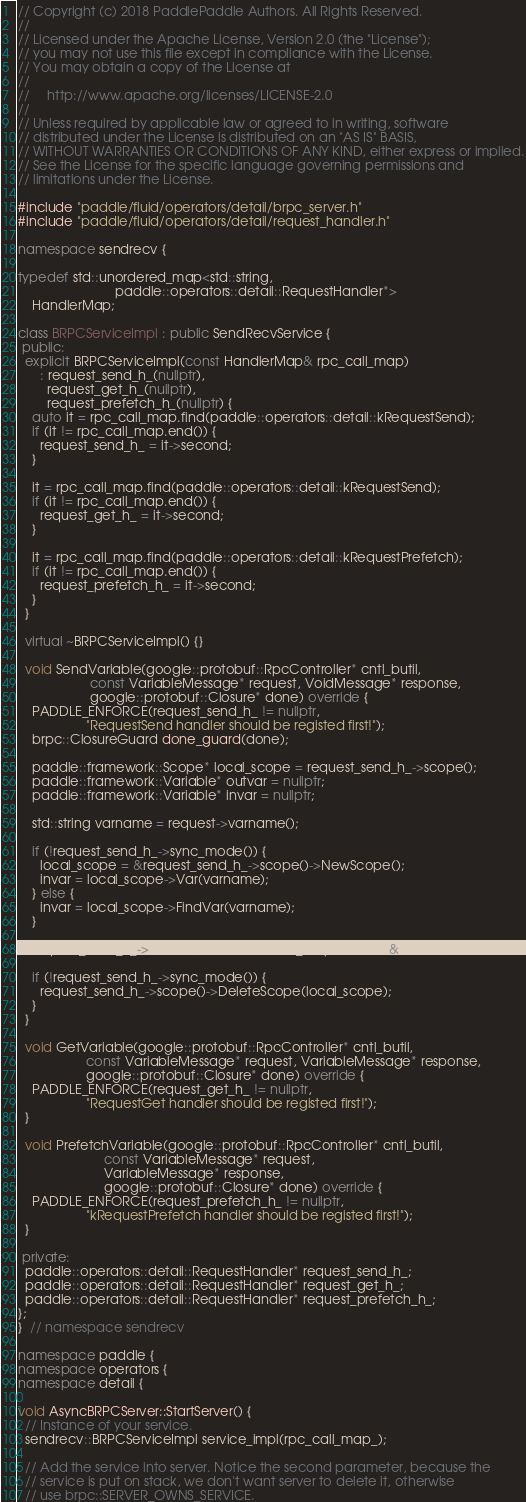<code> <loc_0><loc_0><loc_500><loc_500><_C++_>// Copyright (c) 2018 PaddlePaddle Authors. All Rights Reserved.
//
// Licensed under the Apache License, Version 2.0 (the "License");
// you may not use this file except in compliance with the License.
// You may obtain a copy of the License at
//
//     http://www.apache.org/licenses/LICENSE-2.0
//
// Unless required by applicable law or agreed to in writing, software
// distributed under the License is distributed on an "AS IS" BASIS,
// WITHOUT WARRANTIES OR CONDITIONS OF ANY KIND, either express or implied.
// See the License for the specific language governing permissions and
// limitations under the License.

#include "paddle/fluid/operators/detail/brpc_server.h"
#include "paddle/fluid/operators/detail/request_handler.h"

namespace sendrecv {

typedef std::unordered_map<std::string,
                           paddle::operators::detail::RequestHandler*>
    HandlerMap;

class BRPCServiceImpl : public SendRecvService {
 public:
  explicit BRPCServiceImpl(const HandlerMap& rpc_call_map)
      : request_send_h_(nullptr),
        request_get_h_(nullptr),
        request_prefetch_h_(nullptr) {
    auto it = rpc_call_map.find(paddle::operators::detail::kRequestSend);
    if (it != rpc_call_map.end()) {
      request_send_h_ = it->second;
    }

    it = rpc_call_map.find(paddle::operators::detail::kRequestSend);
    if (it != rpc_call_map.end()) {
      request_get_h_ = it->second;
    }

    it = rpc_call_map.find(paddle::operators::detail::kRequestPrefetch);
    if (it != rpc_call_map.end()) {
      request_prefetch_h_ = it->second;
    }
  }

  virtual ~BRPCServiceImpl() {}

  void SendVariable(google::protobuf::RpcController* cntl_butil,
                    const VariableMessage* request, VoidMessage* response,
                    google::protobuf::Closure* done) override {
    PADDLE_ENFORCE(request_send_h_ != nullptr,
                   "RequestSend handler should be registed first!");
    brpc::ClosureGuard done_guard(done);

    paddle::framework::Scope* local_scope = request_send_h_->scope();
    paddle::framework::Variable* outvar = nullptr;
    paddle::framework::Variable* invar = nullptr;

    std::string varname = request->varname();

    if (!request_send_h_->sync_mode()) {
      local_scope = &request_send_h_->scope()->NewScope();
      invar = local_scope->Var(varname);
    } else {
      invar = local_scope->FindVar(varname);
    }

    request_send_h_->Handle(varname, local_scope, invar, &outvar);

    if (!request_send_h_->sync_mode()) {
      request_send_h_->scope()->DeleteScope(local_scope);
    }
  }

  void GetVariable(google::protobuf::RpcController* cntl_butil,
                   const VariableMessage* request, VariableMessage* response,
                   google::protobuf::Closure* done) override {
    PADDLE_ENFORCE(request_get_h_ != nullptr,
                   "RequestGet handler should be registed first!");
  }

  void PrefetchVariable(google::protobuf::RpcController* cntl_butil,
                        const VariableMessage* request,
                        VariableMessage* response,
                        google::protobuf::Closure* done) override {
    PADDLE_ENFORCE(request_prefetch_h_ != nullptr,
                   "kRequestPrefetch handler should be registed first!");
  }

 private:
  paddle::operators::detail::RequestHandler* request_send_h_;
  paddle::operators::detail::RequestHandler* request_get_h_;
  paddle::operators::detail::RequestHandler* request_prefetch_h_;
};
}  // namespace sendrecv

namespace paddle {
namespace operators {
namespace detail {

void AsyncBRPCServer::StartServer() {
  // Instance of your service.
  sendrecv::BRPCServiceImpl service_impl(rpc_call_map_);

  // Add the service into server. Notice the second parameter, because the
  // service is put on stack, we don't want server to delete it, otherwise
  // use brpc::SERVER_OWNS_SERVICE.</code> 